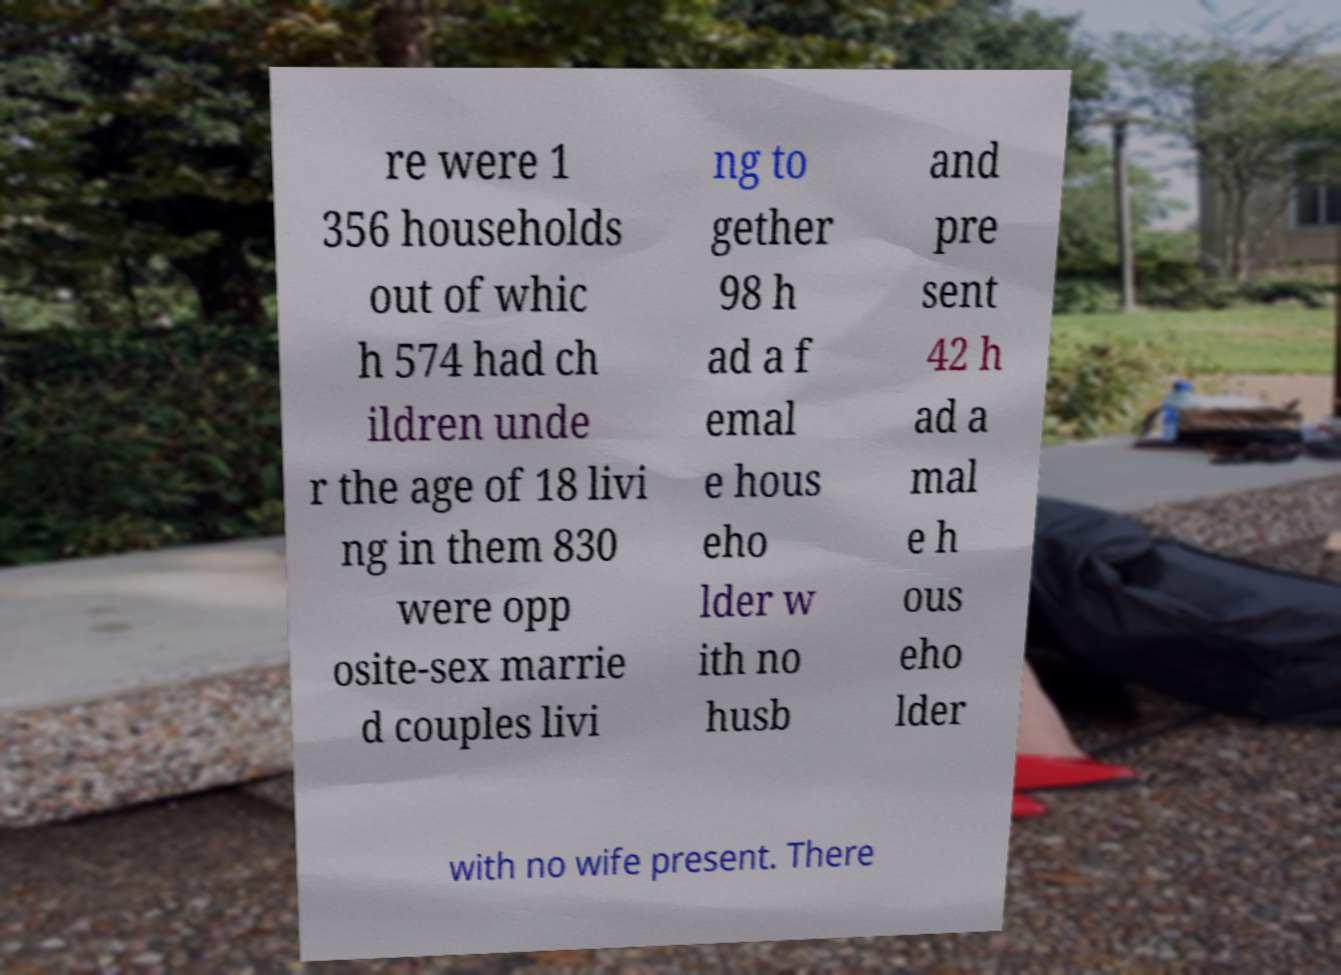Please read and relay the text visible in this image. What does it say? re were 1 356 households out of whic h 574 had ch ildren unde r the age of 18 livi ng in them 830 were opp osite-sex marrie d couples livi ng to gether 98 h ad a f emal e hous eho lder w ith no husb and pre sent 42 h ad a mal e h ous eho lder with no wife present. There 